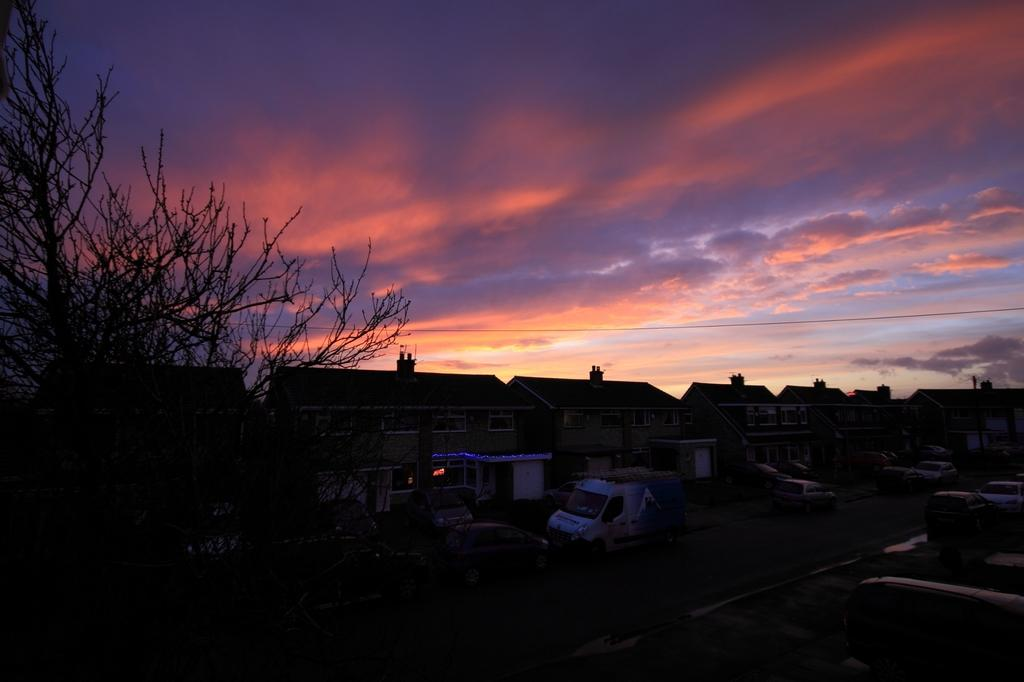What can be seen in the sky in the image? The sky with clouds is visible in the image. What type of structures are present in the image? There are buildings in the image. What mode of transportation can be seen on the road in the image? Vehicles are present on the road in the image. What type of tree is on the left side of the image? There is a bare tree on the left side of the image. How would you describe the lighting in the bottom portion of the image? The bottom portion of the image is dark. How many frogs are sitting on the buildings in the image? There are no frogs present on the buildings in the image. What type of disease is affecting the vehicles on the road in the image? There is no indication of any disease affecting the vehicles in the image; they appear to be functioning normally. 